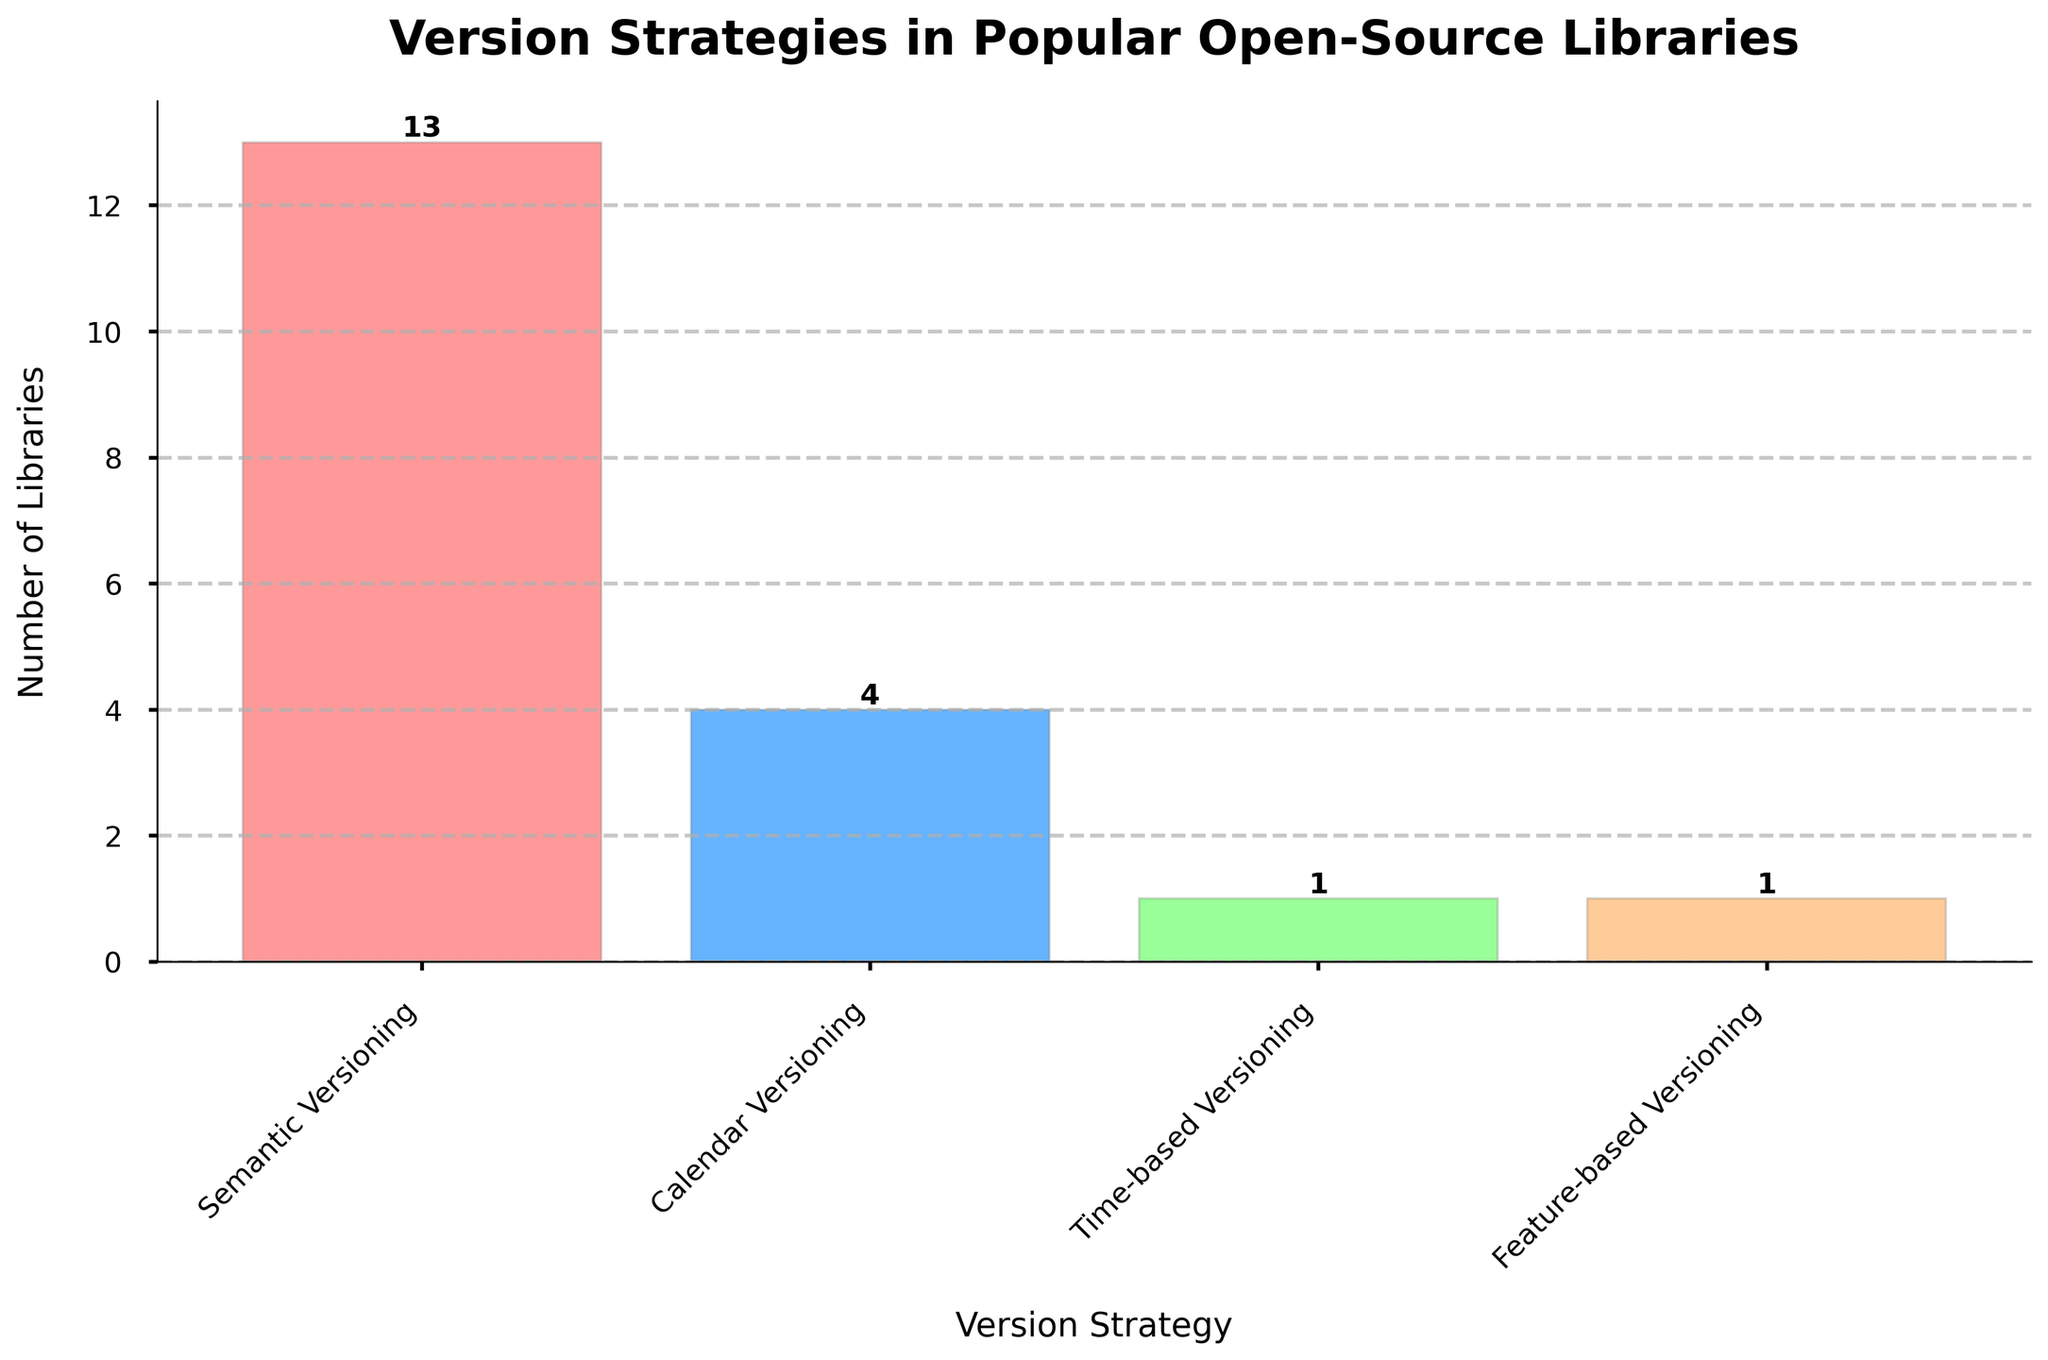1. What is the most common versioning strategy among the libraries? The tallest bar in the bar chart represents the most common versioning strategy. The bar labeled "Semantic Versioning" is the tallest.
Answer: Semantic Versioning 2. How many libraries use Calendar Versioning? Look at the height of the bar labeled "Calendar Versioning". The number on top indicates how many libraries use this strategy, which is 4.
Answer: 4 3. Which versioning strategy is used by the fewest libraries? Identify the shortest bar in the chart. The bar labeled "Feature-based Versioning" is the shortest.
Answer: Feature-based Versioning 4. What is the combined number of libraries using Semantic Versioning and Calendar Versioning? Sum the values on top of the bars for "Semantic Versioning" (13) and "Calendar Versioning" (4). 13 + 4 = 17
Answer: 17 5. How many more libraries use Semantic Versioning compared to Calendar Versioning? Subtract the number of libraries using Calendar Versioning (4) from those using Semantic Versioning (13). 13 - 4 = 9
Answer: 9 6. Visually, which strategy is represented by the red bar and how many libraries use it? The color of the bars helps to visually differentiate them. The red bar represents "Feature-based Versioning" and a value of 1 is shown on top of the bar.
Answer: Feature-based Versioning, 1 7. Compare the number of libraries using Time-based Versioning to those using Feature-based Versioning. Which one is higher and by how much? Check the heights of the bars for both strategies. Time-based Versioning has 1 library, and Feature-based Versioning also has 1 library. Therefore, the difference is 0.
Answer: Equal 8. If one more library started using Calendar Versioning, how many would that be in total? Add 1 to the current number of libraries using Calendar Versioning (4). 4 + 1 = 5
Answer: 5 9. What is the ratio of libraries using Semantic Versioning to those using Calendar Versioning? Divide the number of libraries using Semantic Versioning (13) by those using Calendar Versioning (4). 13 / 4 = 3.25
Answer: 3.25 